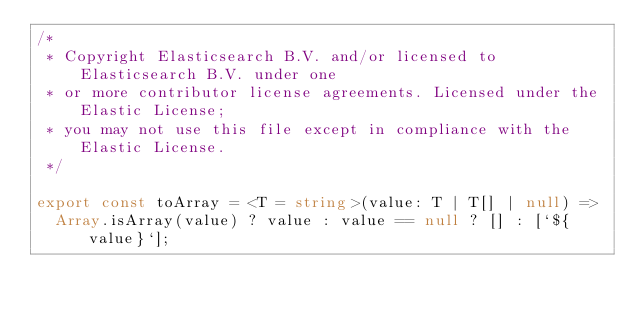<code> <loc_0><loc_0><loc_500><loc_500><_TypeScript_>/*
 * Copyright Elasticsearch B.V. and/or licensed to Elasticsearch B.V. under one
 * or more contributor license agreements. Licensed under the Elastic License;
 * you may not use this file except in compliance with the Elastic License.
 */

export const toArray = <T = string>(value: T | T[] | null) =>
  Array.isArray(value) ? value : value == null ? [] : [`${value}`];
</code> 